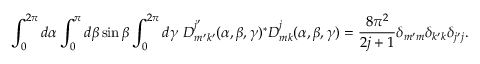<formula> <loc_0><loc_0><loc_500><loc_500>\int _ { 0 } ^ { 2 \pi } d \alpha \int _ { 0 } ^ { \pi } d \beta \sin \beta \int _ { 0 } ^ { 2 \pi } d \gamma \, D _ { m ^ { \prime } k ^ { \prime } } ^ { j ^ { \prime } } ( \alpha , \beta , \gamma ) ^ { \ast } D _ { m k } ^ { j } ( \alpha , \beta , \gamma ) = { \frac { 8 \pi ^ { 2 } } { 2 j + 1 } } \delta _ { m ^ { \prime } m } \delta _ { k ^ { \prime } k } \delta _ { j ^ { \prime } j } .</formula> 